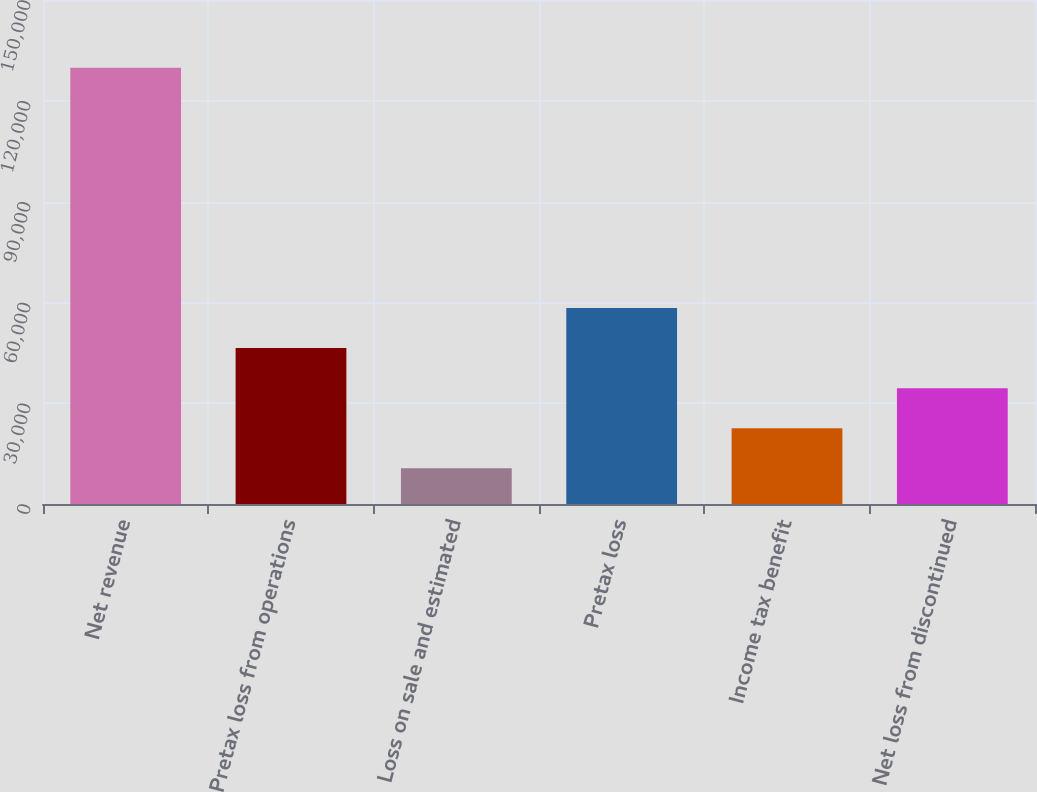<chart> <loc_0><loc_0><loc_500><loc_500><bar_chart><fcel>Net revenue<fcel>Pretax loss from operations<fcel>Loss on sale and estimated<fcel>Pretax loss<fcel>Income tax benefit<fcel>Net loss from discontinued<nl><fcel>129863<fcel>46397.1<fcel>10626<fcel>58320.8<fcel>22549.7<fcel>34473.4<nl></chart> 